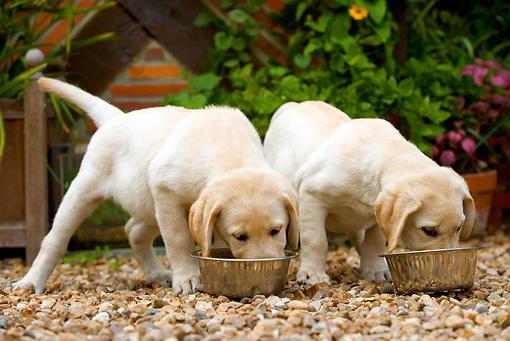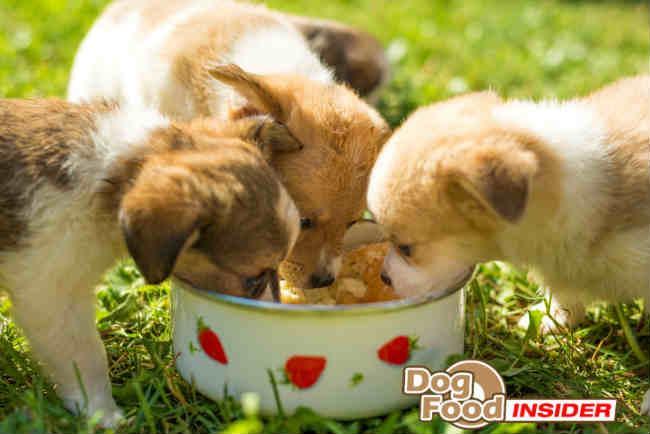The first image is the image on the left, the second image is the image on the right. Evaluate the accuracy of this statement regarding the images: "There are no more than four dogs.". Is it true? Answer yes or no. No. 